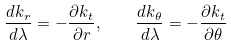Convert formula to latex. <formula><loc_0><loc_0><loc_500><loc_500>\frac { d k _ { r } } { d \lambda } = - \frac { \partial k _ { t } } { \partial r } , \quad \frac { d k _ { \theta } } { d \lambda } = - \frac { \partial k _ { t } } { \partial \theta }</formula> 